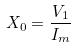<formula> <loc_0><loc_0><loc_500><loc_500>X _ { 0 } = \frac { V _ { 1 } } { I _ { m } }</formula> 